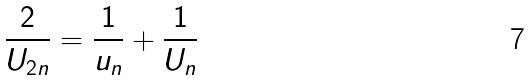Convert formula to latex. <formula><loc_0><loc_0><loc_500><loc_500>\frac { 2 } { U _ { 2 n } } = \frac { 1 } { u _ { n } } + \frac { 1 } { U _ { n } }</formula> 